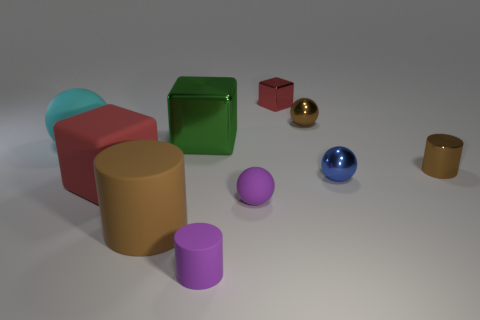Subtract all rubber blocks. How many blocks are left? 2 Subtract all brown spheres. How many spheres are left? 3 Subtract 2 cylinders. How many cylinders are left? 1 Subtract all cyan blocks. How many purple cylinders are left? 1 Subtract all matte cylinders. Subtract all red things. How many objects are left? 6 Add 4 big brown rubber objects. How many big brown rubber objects are left? 5 Add 4 tiny metal cylinders. How many tiny metal cylinders exist? 5 Subtract 2 red blocks. How many objects are left? 8 Subtract all balls. How many objects are left? 6 Subtract all blue cylinders. Subtract all purple spheres. How many cylinders are left? 3 